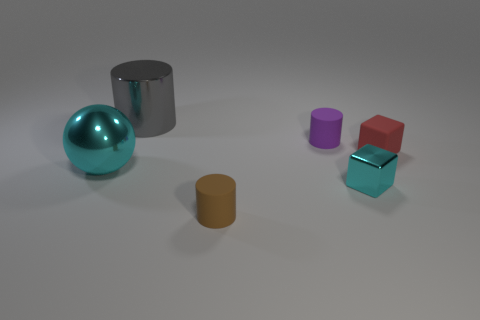There is a small cyan thing that is the same material as the big gray cylinder; what is its shape?
Provide a short and direct response. Cube. What number of big things are metal objects or gray metal things?
Provide a succinct answer. 2. Is there a tiny red matte object that is behind the big object left of the gray thing?
Keep it short and to the point. Yes. Is there a large cylinder?
Offer a terse response. Yes. There is a cylinder on the right side of the small matte thing that is in front of the cyan ball; what color is it?
Make the answer very short. Purple. There is another large object that is the same shape as the brown thing; what is it made of?
Make the answer very short. Metal. How many other cyan cubes are the same size as the matte cube?
Ensure brevity in your answer.  1. There is a cyan block that is made of the same material as the gray cylinder; what is its size?
Offer a terse response. Small. What number of other small objects are the same shape as the red thing?
Keep it short and to the point. 1. How many blue cylinders are there?
Give a very brief answer. 0. 